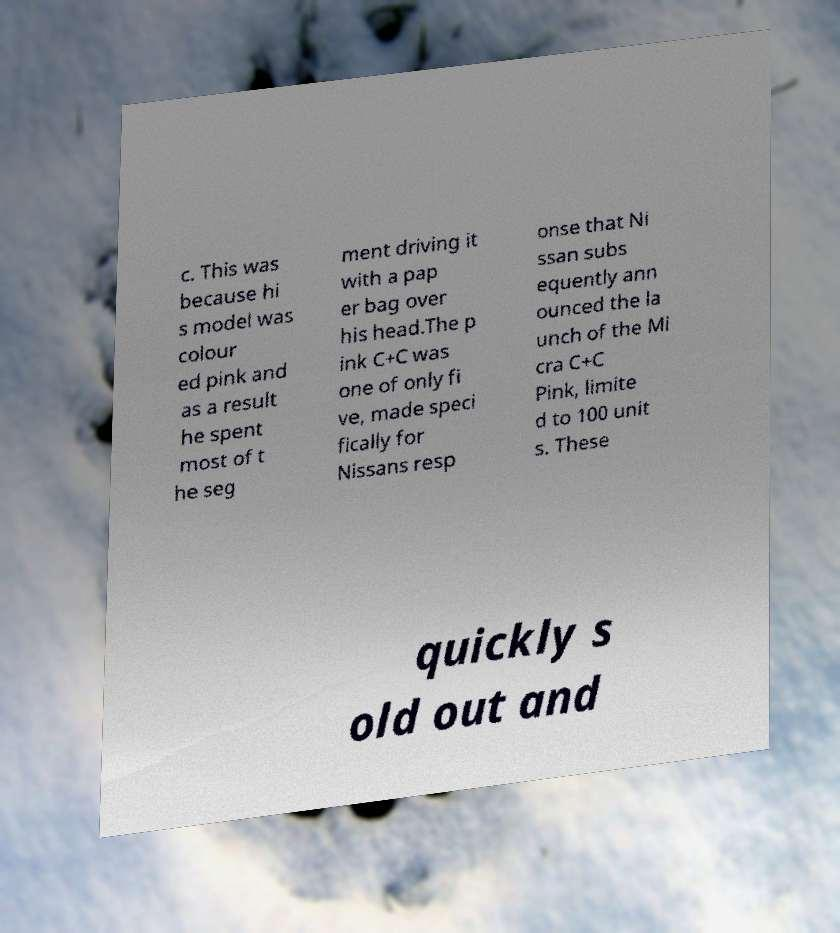Please identify and transcribe the text found in this image. c. This was because hi s model was colour ed pink and as a result he spent most of t he seg ment driving it with a pap er bag over his head.The p ink C+C was one of only fi ve, made speci fically for Nissans resp onse that Ni ssan subs equently ann ounced the la unch of the Mi cra C+C Pink, limite d to 100 unit s. These quickly s old out and 